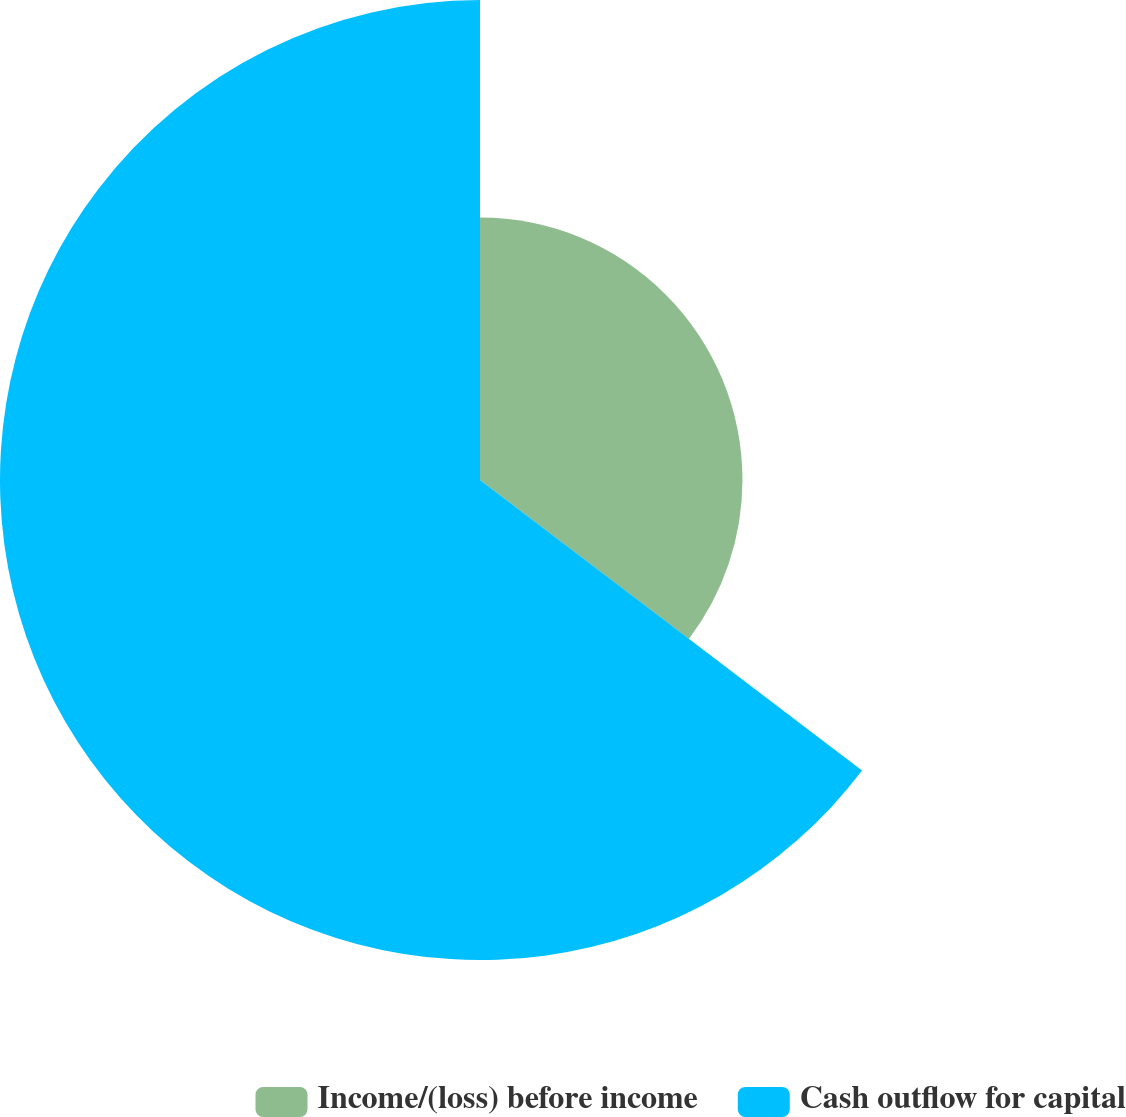<chart> <loc_0><loc_0><loc_500><loc_500><pie_chart><fcel>Income/(loss) before income<fcel>Cash outflow for capital<nl><fcel>35.35%<fcel>64.65%<nl></chart> 